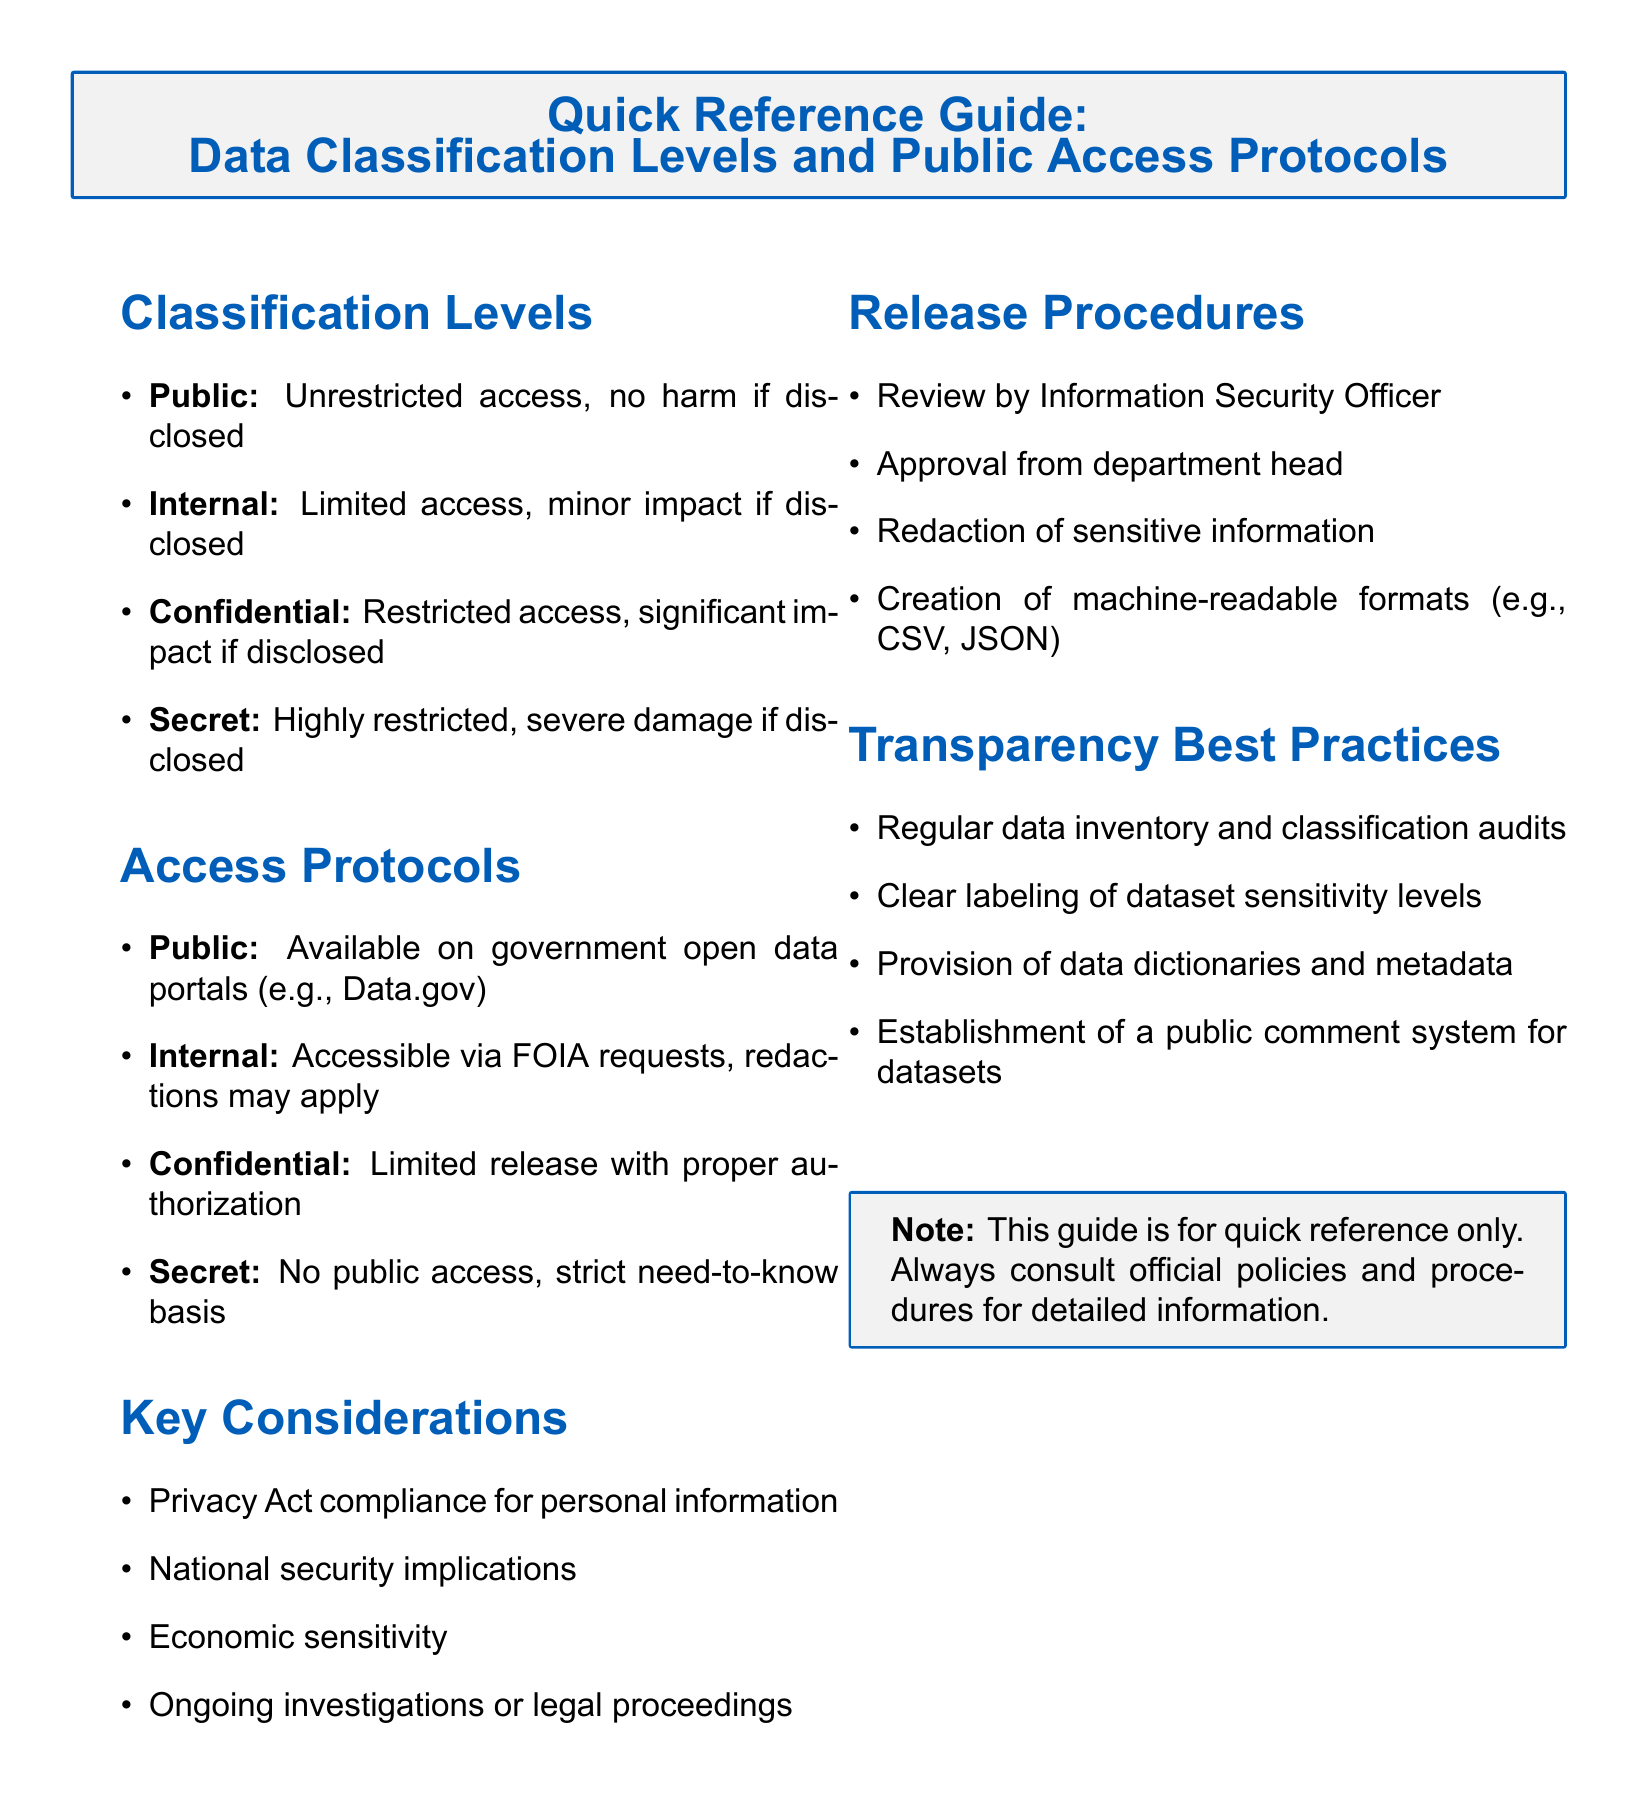What are the four classification levels? The document lists the classification levels as Public, Internal, Confidential, and Secret.
Answer: Public, Internal, Confidential, Secret What does "Public" classification mean? The document explains that Public classification allows unrestricted access with no harm if disclosed.
Answer: Unrestricted access, no harm if disclosed What is the access protocol for "Confidential" data? According to the document, Confidential data requires limited release with proper authorization.
Answer: Limited release with proper authorization Which section addresses the best practices for transparency? The Transparency Best Practices section specifically discusses practices for enhancing transparency regarding datasets.
Answer: Transparency Best Practices What is a key consideration listed in the document? The document highlights several key considerations, one of which is Privacy Act compliance for personal information.
Answer: Privacy Act compliance for personal information How many procedures are outlined in the Release Procedures section? The document specifies four procedures in the Release Procedures section.
Answer: Four Where can "Public" data be accessed? The document indicates that Public data is available on government open data portals, for example, Data.gov.
Answer: Government open data portals (e.g., Data.gov) What is required before releasing data classified as "Secret"? The document states that Secret data has no public access and is based on a strict need-to-know basis.
Answer: No public access, strict need-to-know basis 